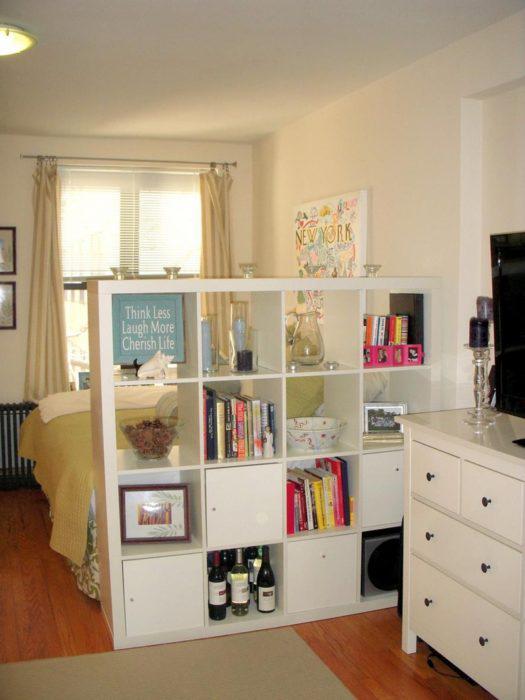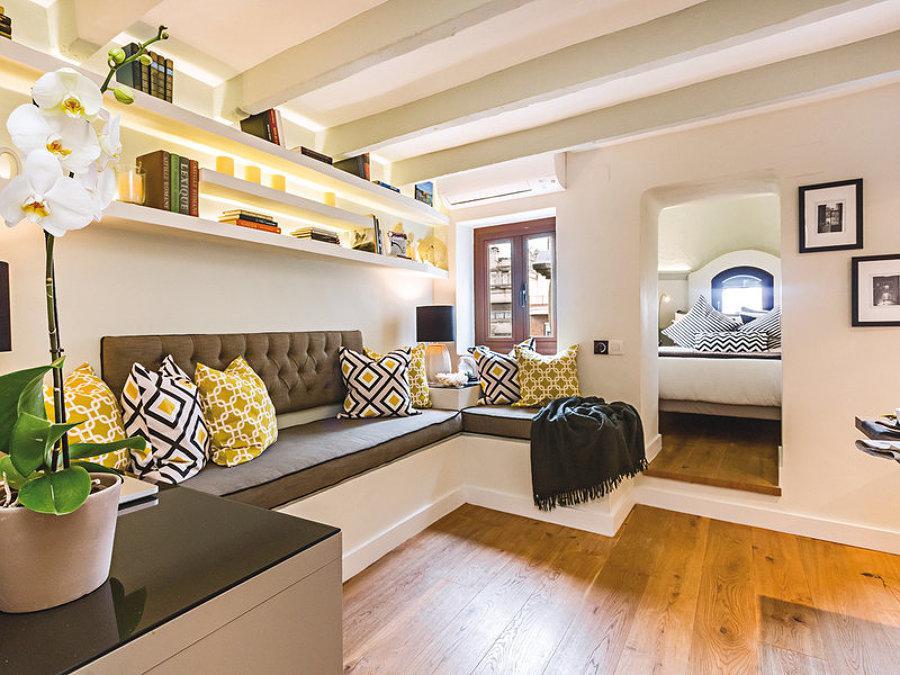The first image is the image on the left, the second image is the image on the right. Given the left and right images, does the statement "In at least one image, there's a white shelf blocking a bed from view." hold true? Answer yes or no. Yes. 